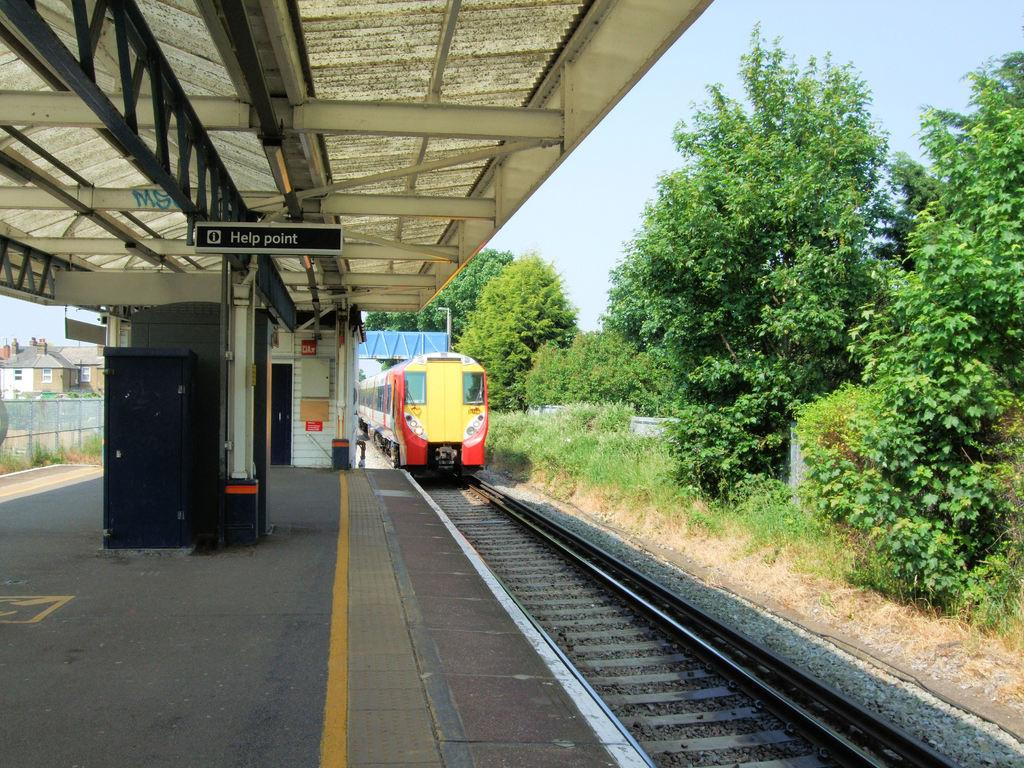<image>
Create a compact narrative representing the image presented. Train going to a station that says "Help Point" on it. 